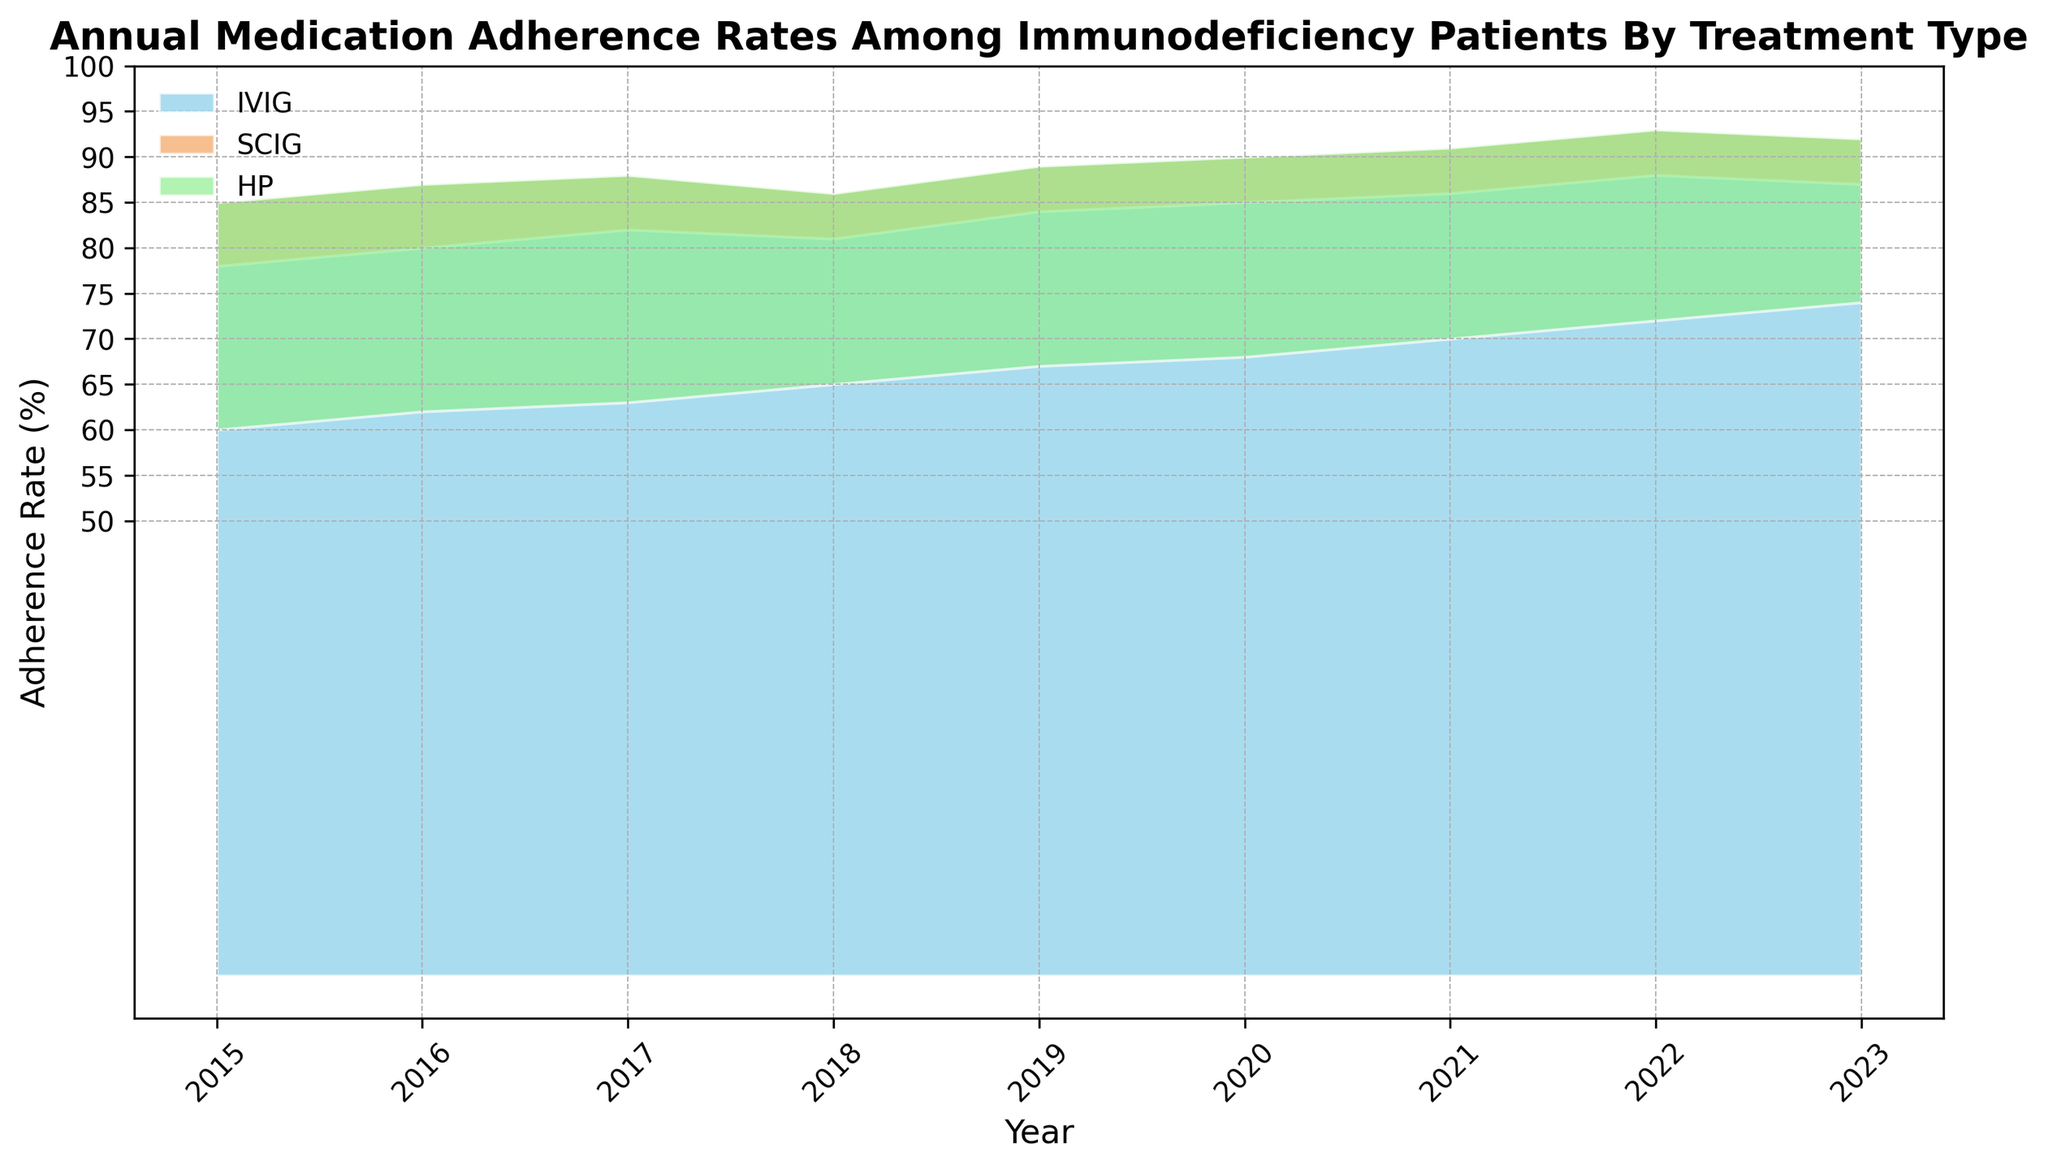What year shows the highest adherence rate for the SCIG treatment? Look at the topmost values for the SCIG segment in the area chart. The peak for SCIG is in 2022 with a rate of 93%.
Answer: 2022 During which year was the difference in adherence rates between IVIG and HP the largest? Identify the annual differences by reading the graph's segments for IVIG and HP and calculating the gap each year. The largest gap appears in 2017, where IVIG is 82%, and HP is 63%, giving a difference of 19%.
Answer: 2017 Which treatment showed a consistent increasing trend in adherence rates over the years? Follow the trendlines of each treatment segment from left to right. SCIG shows a consistent increase each year without any dips.
Answer: SCIG From 2015 to 2023, what is the average adherence rate for the IVIG treatment? Add up IVIG's adherence rates for each year and divide by the number of years. Sum is (78 + 80 + 82 + 81 + 84 + 85 + 86 + 88 + 87) = 751, so the average is 751/9 ≈ 83.44%.
Answer: 83.44% In 2021, how does the adherence rate for HP compare to IVIG and SCIG? Refer to 2021: HP has an adherence rate of 70%, IVIG has 86%, and SCIG has 91%. HP's rate is lower than both IVIG and SCIG.
Answer: Lower In which year did IVIG have the same adherence rate as the average rate for HP across all years? Calculate the average adherence rate for HP: (60 + 62 + 63 + 65 + 67 + 68 + 70 + 72 + 74) = 601; 601/9 ≈ 66.78. IVIG never matches 66.78% exactly, but it comes close in 2018 at 81%, which can be interpreted as the closest match.
Answer: Never, closest in 2018 Which two treatment types have the closest adherence rates in 2020? Examine the adherence rates for 2020: IVIG is 85%, SCIG is 90%, and HP is 68%. The rates for IVIG and SCIG are closest, with only a 5% difference.
Answer: IVIG and SCIG Looking at the trends, which treatment saw the least fluctuation in adherence rates from 2015 to 2023? Observe the smoothness and consistency of each segment. SCIG exhibits the most stable rise in rates with minor fluctuation.
Answer: SCIG 